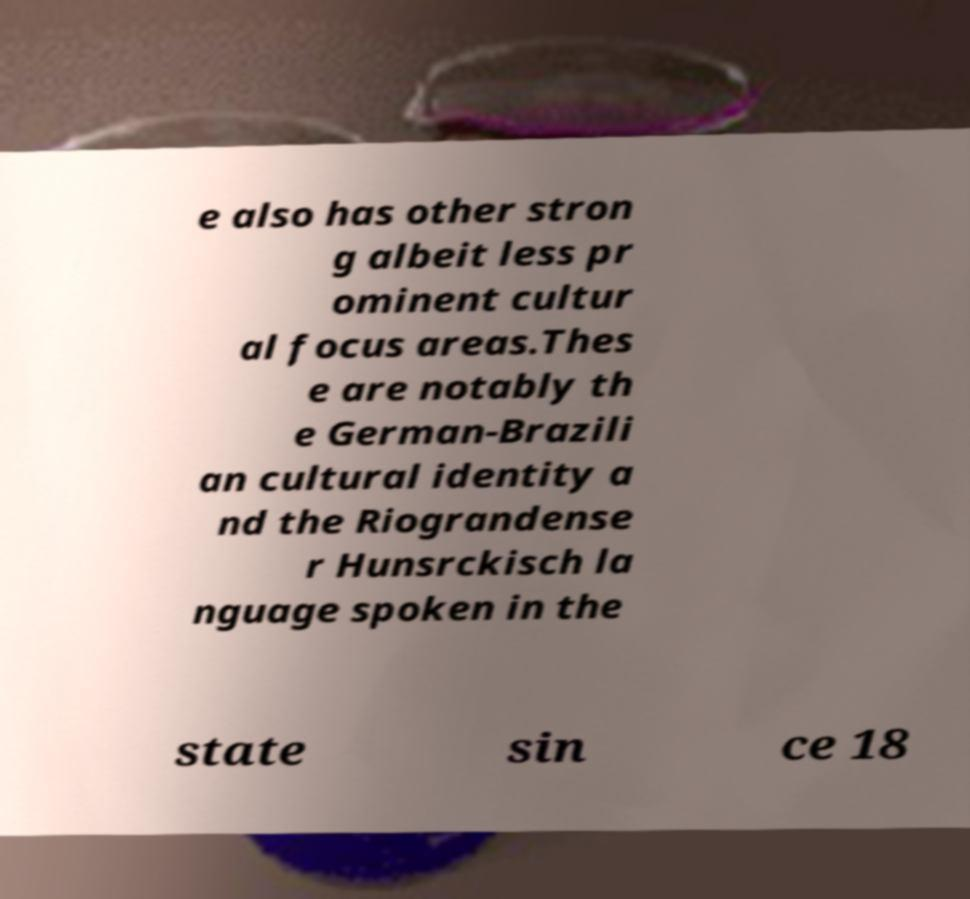For documentation purposes, I need the text within this image transcribed. Could you provide that? e also has other stron g albeit less pr ominent cultur al focus areas.Thes e are notably th e German-Brazili an cultural identity a nd the Riograndense r Hunsrckisch la nguage spoken in the state sin ce 18 